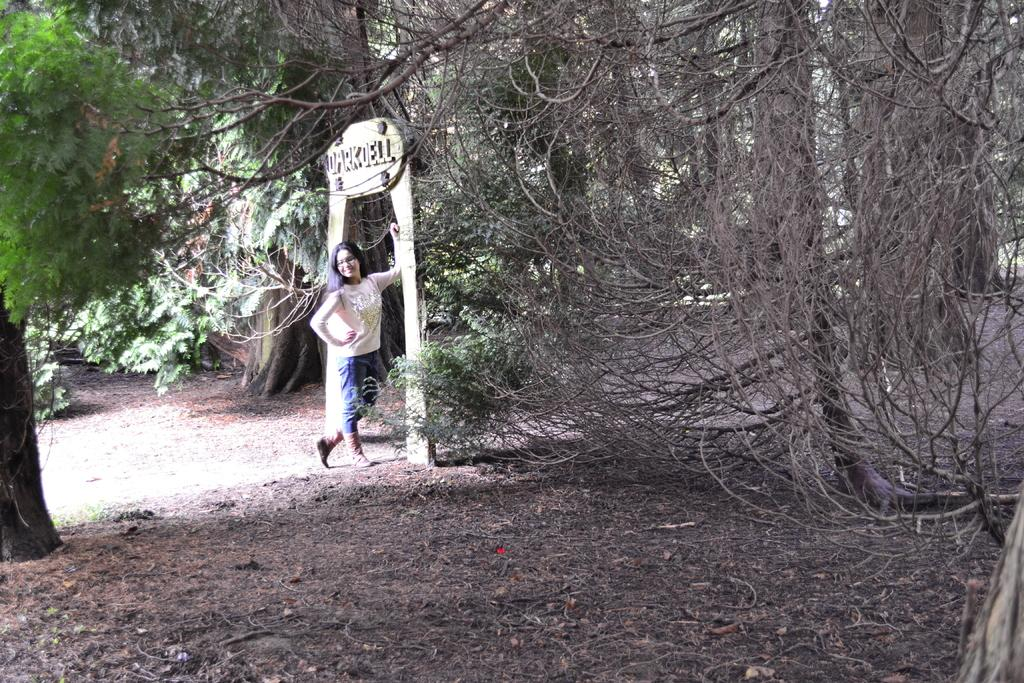Who is present in the image? There is a woman in the image. What is the woman wearing? The woman is wearing a T-shirt and pants. Where is the woman standing in the image? The woman is standing near an arch. What type of vegetation can be seen in the image? There are green trees and dry trees in the image. What is the reaction of the sheep to the pollution in the image? There are no sheep or pollution present in the image. 